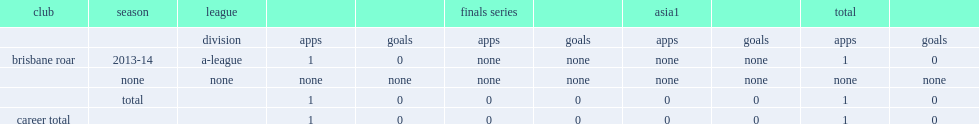Which club did patrick theodore play for in 2013-14? Brisbane roar. 